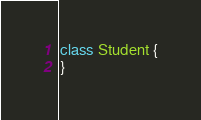<code> <loc_0><loc_0><loc_500><loc_500><_Kotlin_>
class Student {
}</code> 